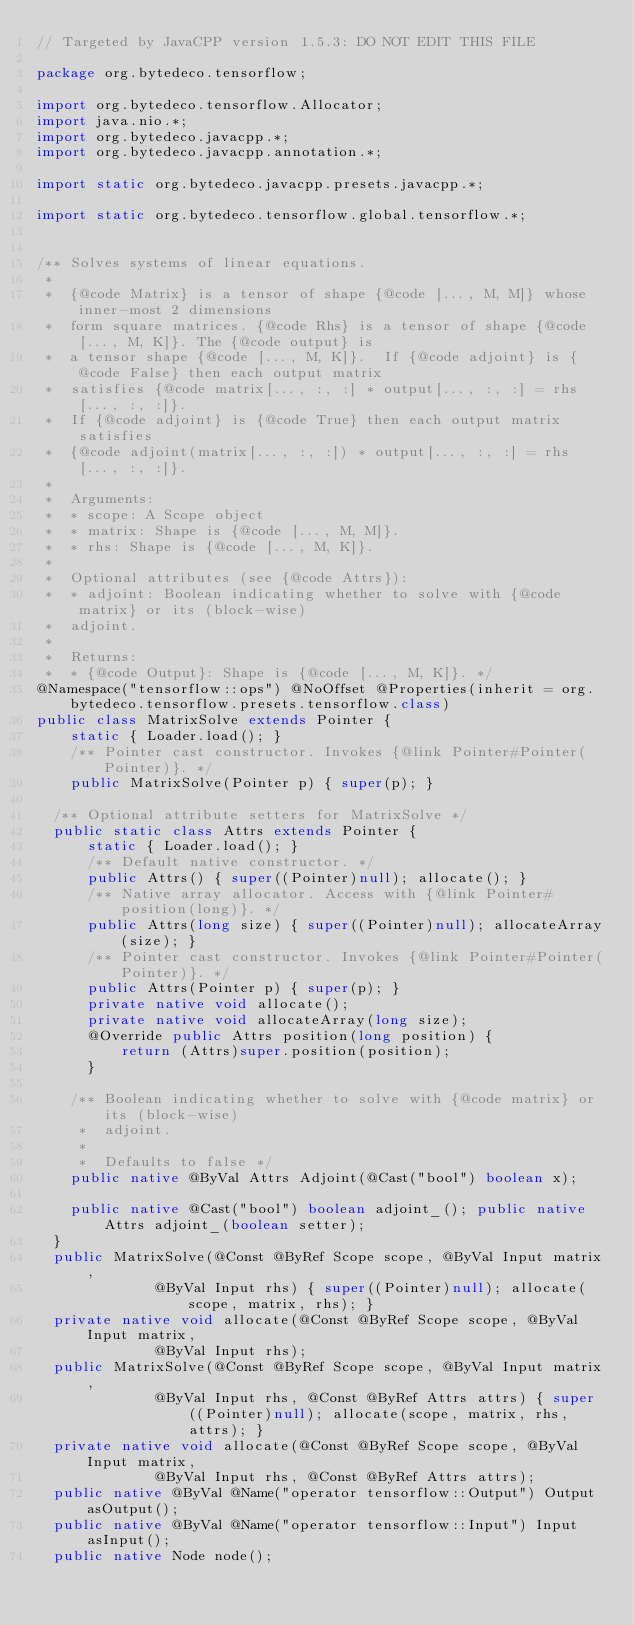<code> <loc_0><loc_0><loc_500><loc_500><_Java_>// Targeted by JavaCPP version 1.5.3: DO NOT EDIT THIS FILE

package org.bytedeco.tensorflow;

import org.bytedeco.tensorflow.Allocator;
import java.nio.*;
import org.bytedeco.javacpp.*;
import org.bytedeco.javacpp.annotation.*;

import static org.bytedeco.javacpp.presets.javacpp.*;

import static org.bytedeco.tensorflow.global.tensorflow.*;


/** Solves systems of linear equations.
 * 
 *  {@code Matrix} is a tensor of shape {@code [..., M, M]} whose inner-most 2 dimensions
 *  form square matrices. {@code Rhs} is a tensor of shape {@code [..., M, K]}. The {@code output} is
 *  a tensor shape {@code [..., M, K]}.  If {@code adjoint} is {@code False} then each output matrix
 *  satisfies {@code matrix[..., :, :] * output[..., :, :] = rhs[..., :, :]}.
 *  If {@code adjoint} is {@code True} then each output matrix satisfies
 *  {@code adjoint(matrix[..., :, :]) * output[..., :, :] = rhs[..., :, :]}.
 * 
 *  Arguments:
 *  * scope: A Scope object
 *  * matrix: Shape is {@code [..., M, M]}.
 *  * rhs: Shape is {@code [..., M, K]}.
 * 
 *  Optional attributes (see {@code Attrs}):
 *  * adjoint: Boolean indicating whether to solve with {@code matrix} or its (block-wise)
 *  adjoint.
 * 
 *  Returns:
 *  * {@code Output}: Shape is {@code [..., M, K]}. */
@Namespace("tensorflow::ops") @NoOffset @Properties(inherit = org.bytedeco.tensorflow.presets.tensorflow.class)
public class MatrixSolve extends Pointer {
    static { Loader.load(); }
    /** Pointer cast constructor. Invokes {@link Pointer#Pointer(Pointer)}. */
    public MatrixSolve(Pointer p) { super(p); }

  /** Optional attribute setters for MatrixSolve */
  public static class Attrs extends Pointer {
      static { Loader.load(); }
      /** Default native constructor. */
      public Attrs() { super((Pointer)null); allocate(); }
      /** Native array allocator. Access with {@link Pointer#position(long)}. */
      public Attrs(long size) { super((Pointer)null); allocateArray(size); }
      /** Pointer cast constructor. Invokes {@link Pointer#Pointer(Pointer)}. */
      public Attrs(Pointer p) { super(p); }
      private native void allocate();
      private native void allocateArray(long size);
      @Override public Attrs position(long position) {
          return (Attrs)super.position(position);
      }
  
    /** Boolean indicating whether to solve with {@code matrix} or its (block-wise)
     *  adjoint.
     * 
     *  Defaults to false */
    public native @ByVal Attrs Adjoint(@Cast("bool") boolean x);

    public native @Cast("bool") boolean adjoint_(); public native Attrs adjoint_(boolean setter);
  }
  public MatrixSolve(@Const @ByRef Scope scope, @ByVal Input matrix,
              @ByVal Input rhs) { super((Pointer)null); allocate(scope, matrix, rhs); }
  private native void allocate(@Const @ByRef Scope scope, @ByVal Input matrix,
              @ByVal Input rhs);
  public MatrixSolve(@Const @ByRef Scope scope, @ByVal Input matrix,
              @ByVal Input rhs, @Const @ByRef Attrs attrs) { super((Pointer)null); allocate(scope, matrix, rhs, attrs); }
  private native void allocate(@Const @ByRef Scope scope, @ByVal Input matrix,
              @ByVal Input rhs, @Const @ByRef Attrs attrs);
  public native @ByVal @Name("operator tensorflow::Output") Output asOutput();
  public native @ByVal @Name("operator tensorflow::Input") Input asInput();
  public native Node node();
</code> 